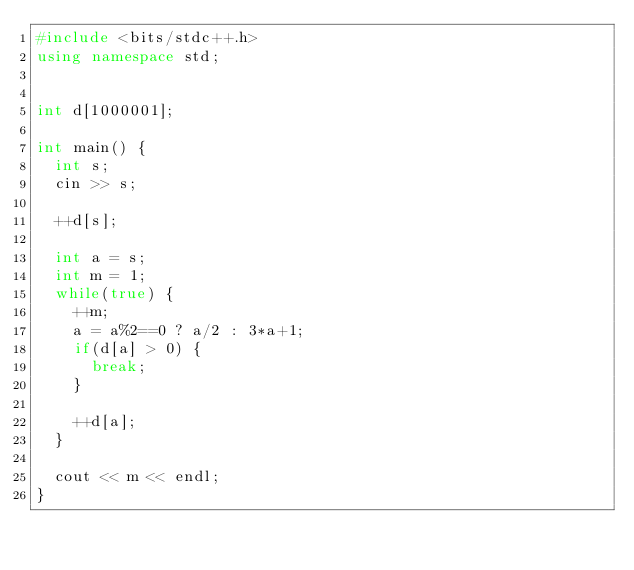Convert code to text. <code><loc_0><loc_0><loc_500><loc_500><_C++_>#include <bits/stdc++.h>
using namespace std;


int d[1000001];

int main() {
  int s;
  cin >> s;

  ++d[s];

  int a = s;
  int m = 1;
  while(true) {
    ++m;
    a = a%2==0 ? a/2 : 3*a+1;
    if(d[a] > 0) {
      break;
    }

    ++d[a];
  }

  cout << m << endl;
}
</code> 